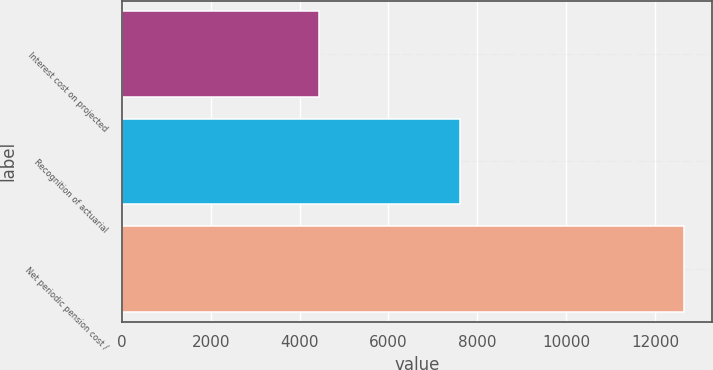<chart> <loc_0><loc_0><loc_500><loc_500><bar_chart><fcel>Interest cost on projected<fcel>Recognition of actuarial<fcel>Net periodic pension cost /<nl><fcel>4428<fcel>7606<fcel>12648<nl></chart> 